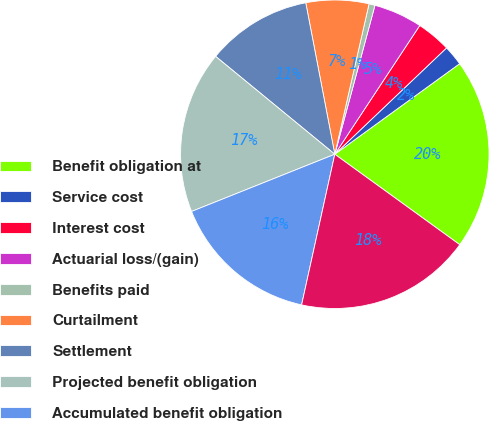Convert chart. <chart><loc_0><loc_0><loc_500><loc_500><pie_chart><fcel>Benefit obligation at<fcel>Service cost<fcel>Interest cost<fcel>Actuarial loss/(gain)<fcel>Benefits paid<fcel>Curtailment<fcel>Settlement<fcel>Projected benefit obligation<fcel>Accumulated benefit obligation<fcel>Fair value of plan assets at<nl><fcel>19.96%<fcel>2.12%<fcel>3.61%<fcel>5.09%<fcel>0.63%<fcel>6.58%<fcel>11.04%<fcel>16.99%<fcel>15.5%<fcel>18.48%<nl></chart> 